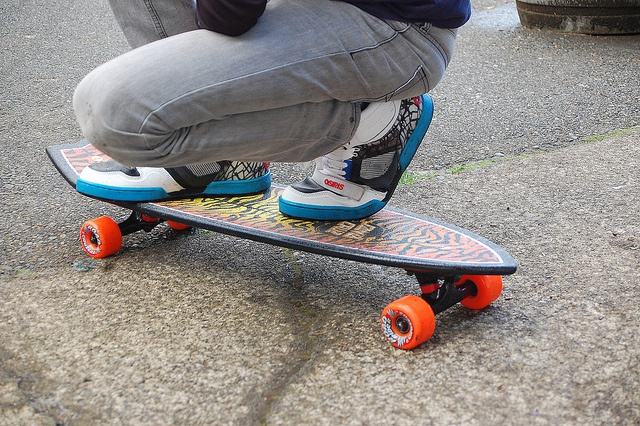Describe the objects in this image and their specific colors. I can see people in gray, darkgray, black, and lightgray tones and skateboard in gray, black, lightgray, and darkgray tones in this image. 